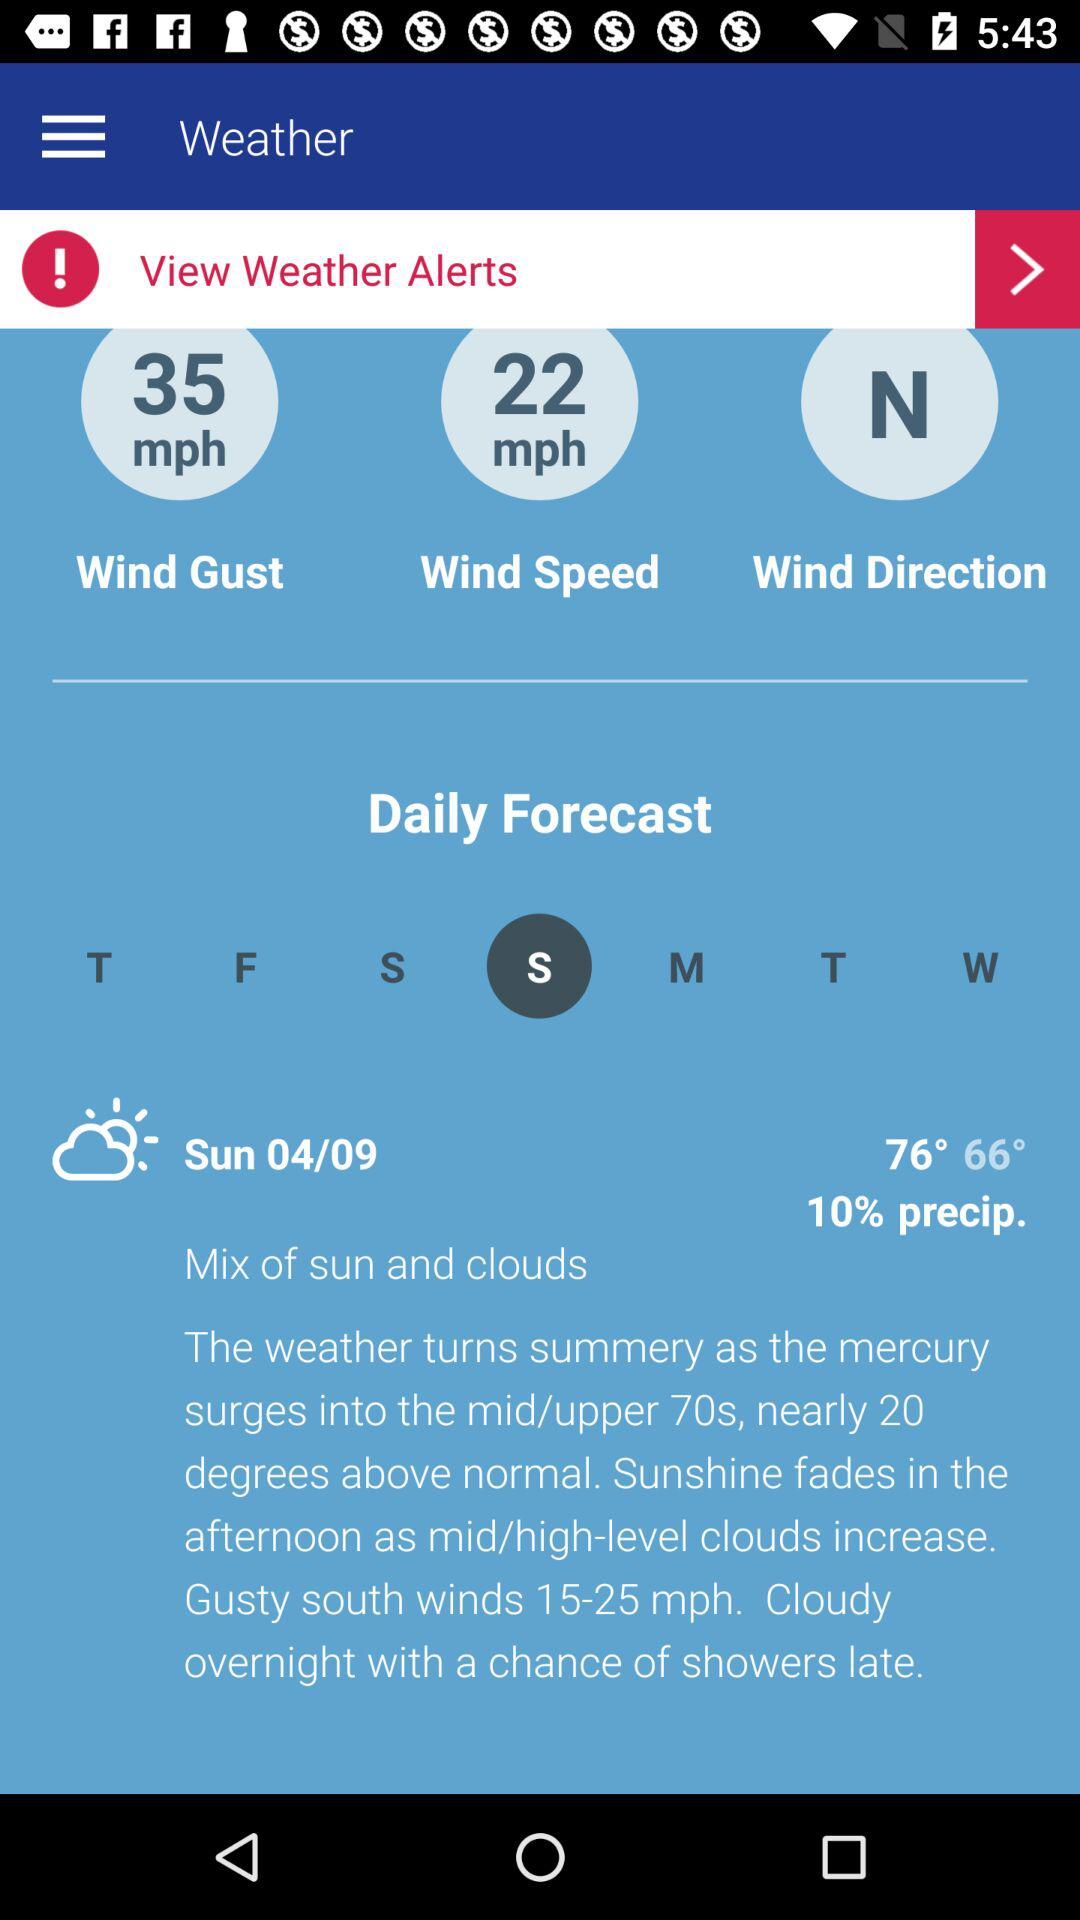What is the difference in wind speed between the gust and the regular speed?
Answer the question using a single word or phrase. 13 mph 